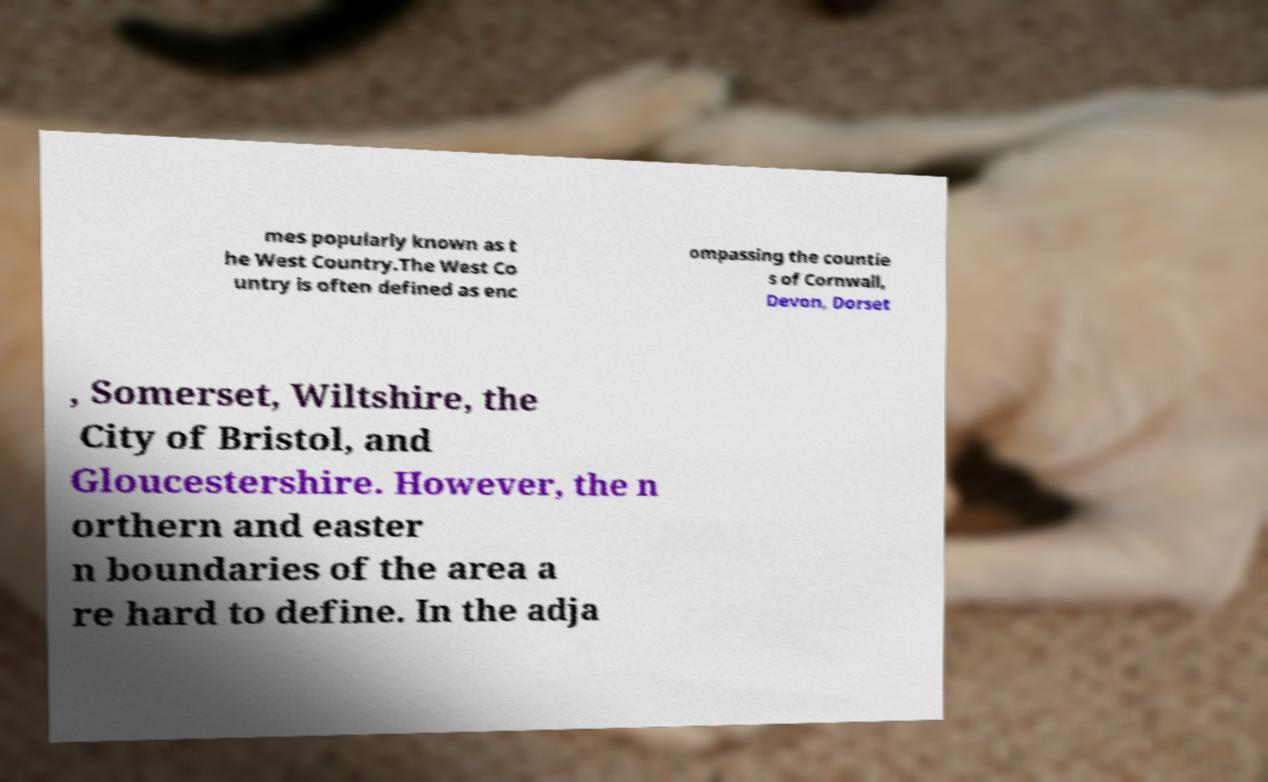Could you assist in decoding the text presented in this image and type it out clearly? mes popularly known as t he West Country.The West Co untry is often defined as enc ompassing the countie s of Cornwall, Devon, Dorset , Somerset, Wiltshire, the City of Bristol, and Gloucestershire. However, the n orthern and easter n boundaries of the area a re hard to define. In the adja 